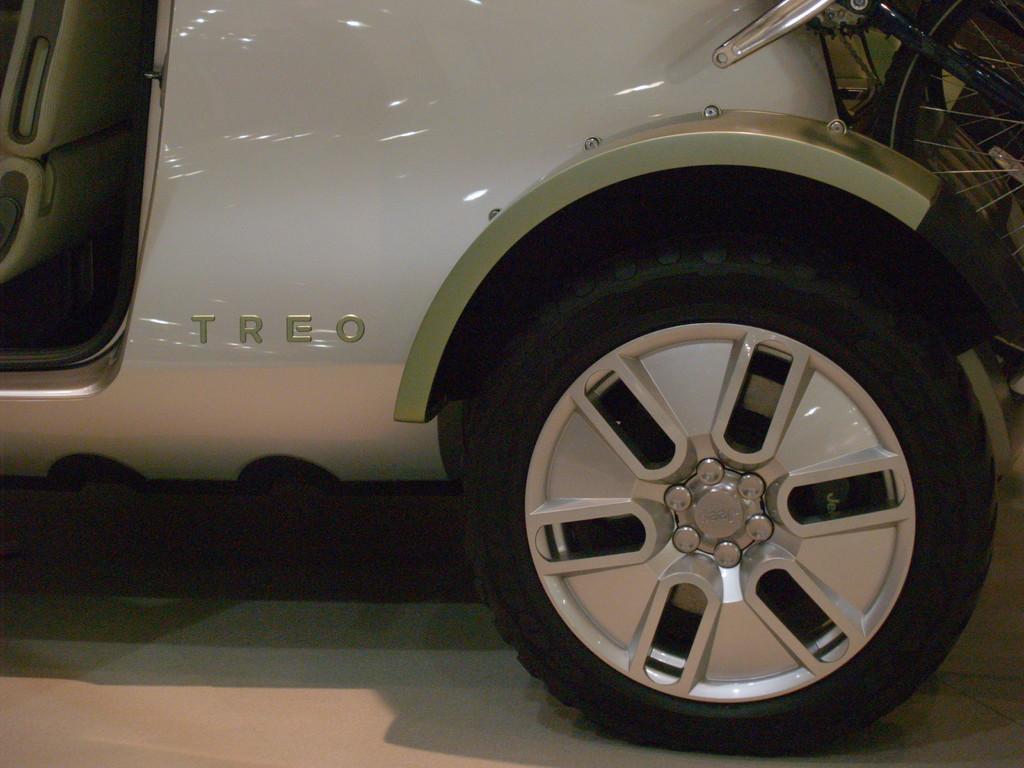Could you give a brief overview of what you see in this image? In this image I can see a car on the ground and a wheel attached to the car. 